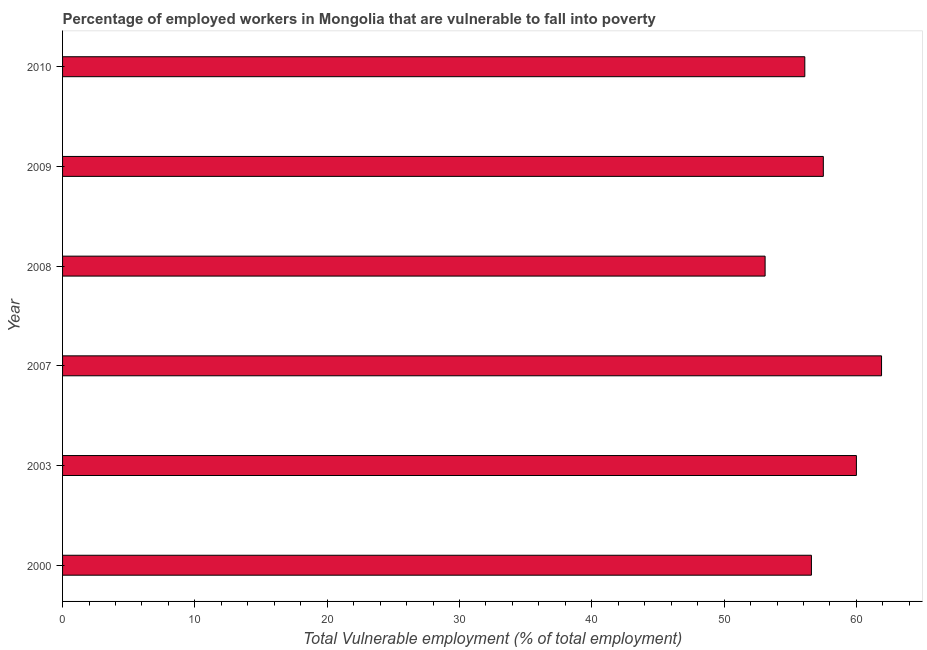Does the graph contain any zero values?
Keep it short and to the point. No. What is the title of the graph?
Your answer should be very brief. Percentage of employed workers in Mongolia that are vulnerable to fall into poverty. What is the label or title of the X-axis?
Your answer should be compact. Total Vulnerable employment (% of total employment). What is the label or title of the Y-axis?
Make the answer very short. Year. What is the total vulnerable employment in 2000?
Make the answer very short. 56.6. Across all years, what is the maximum total vulnerable employment?
Offer a very short reply. 61.9. Across all years, what is the minimum total vulnerable employment?
Offer a terse response. 53.1. In which year was the total vulnerable employment maximum?
Provide a succinct answer. 2007. What is the sum of the total vulnerable employment?
Provide a short and direct response. 345.2. What is the average total vulnerable employment per year?
Provide a short and direct response. 57.53. What is the median total vulnerable employment?
Make the answer very short. 57.05. Do a majority of the years between 2009 and 2007 (inclusive) have total vulnerable employment greater than 20 %?
Your answer should be compact. Yes. What is the ratio of the total vulnerable employment in 2003 to that in 2008?
Your answer should be compact. 1.13. Is the total vulnerable employment in 2000 less than that in 2010?
Keep it short and to the point. No. Is the difference between the total vulnerable employment in 2000 and 2010 greater than the difference between any two years?
Provide a short and direct response. No. What is the difference between the highest and the second highest total vulnerable employment?
Keep it short and to the point. 1.9. Is the sum of the total vulnerable employment in 2003 and 2008 greater than the maximum total vulnerable employment across all years?
Your answer should be very brief. Yes. In how many years, is the total vulnerable employment greater than the average total vulnerable employment taken over all years?
Make the answer very short. 2. Are all the bars in the graph horizontal?
Your answer should be compact. Yes. How many years are there in the graph?
Provide a short and direct response. 6. What is the difference between two consecutive major ticks on the X-axis?
Your answer should be compact. 10. Are the values on the major ticks of X-axis written in scientific E-notation?
Keep it short and to the point. No. What is the Total Vulnerable employment (% of total employment) in 2000?
Your answer should be very brief. 56.6. What is the Total Vulnerable employment (% of total employment) in 2003?
Your answer should be very brief. 60. What is the Total Vulnerable employment (% of total employment) of 2007?
Give a very brief answer. 61.9. What is the Total Vulnerable employment (% of total employment) in 2008?
Offer a terse response. 53.1. What is the Total Vulnerable employment (% of total employment) in 2009?
Your answer should be very brief. 57.5. What is the Total Vulnerable employment (% of total employment) in 2010?
Your answer should be compact. 56.1. What is the difference between the Total Vulnerable employment (% of total employment) in 2000 and 2003?
Your answer should be very brief. -3.4. What is the difference between the Total Vulnerable employment (% of total employment) in 2000 and 2007?
Ensure brevity in your answer.  -5.3. What is the difference between the Total Vulnerable employment (% of total employment) in 2000 and 2010?
Provide a short and direct response. 0.5. What is the difference between the Total Vulnerable employment (% of total employment) in 2003 and 2008?
Give a very brief answer. 6.9. What is the difference between the Total Vulnerable employment (% of total employment) in 2007 and 2008?
Ensure brevity in your answer.  8.8. What is the difference between the Total Vulnerable employment (% of total employment) in 2007 and 2009?
Your answer should be very brief. 4.4. What is the difference between the Total Vulnerable employment (% of total employment) in 2008 and 2010?
Keep it short and to the point. -3. What is the ratio of the Total Vulnerable employment (% of total employment) in 2000 to that in 2003?
Give a very brief answer. 0.94. What is the ratio of the Total Vulnerable employment (% of total employment) in 2000 to that in 2007?
Ensure brevity in your answer.  0.91. What is the ratio of the Total Vulnerable employment (% of total employment) in 2000 to that in 2008?
Offer a terse response. 1.07. What is the ratio of the Total Vulnerable employment (% of total employment) in 2000 to that in 2009?
Your answer should be compact. 0.98. What is the ratio of the Total Vulnerable employment (% of total employment) in 2003 to that in 2007?
Ensure brevity in your answer.  0.97. What is the ratio of the Total Vulnerable employment (% of total employment) in 2003 to that in 2008?
Provide a succinct answer. 1.13. What is the ratio of the Total Vulnerable employment (% of total employment) in 2003 to that in 2009?
Your answer should be very brief. 1.04. What is the ratio of the Total Vulnerable employment (% of total employment) in 2003 to that in 2010?
Provide a succinct answer. 1.07. What is the ratio of the Total Vulnerable employment (% of total employment) in 2007 to that in 2008?
Keep it short and to the point. 1.17. What is the ratio of the Total Vulnerable employment (% of total employment) in 2007 to that in 2009?
Provide a succinct answer. 1.08. What is the ratio of the Total Vulnerable employment (% of total employment) in 2007 to that in 2010?
Your answer should be compact. 1.1. What is the ratio of the Total Vulnerable employment (% of total employment) in 2008 to that in 2009?
Your answer should be compact. 0.92. What is the ratio of the Total Vulnerable employment (% of total employment) in 2008 to that in 2010?
Your answer should be very brief. 0.95. What is the ratio of the Total Vulnerable employment (% of total employment) in 2009 to that in 2010?
Provide a succinct answer. 1.02. 